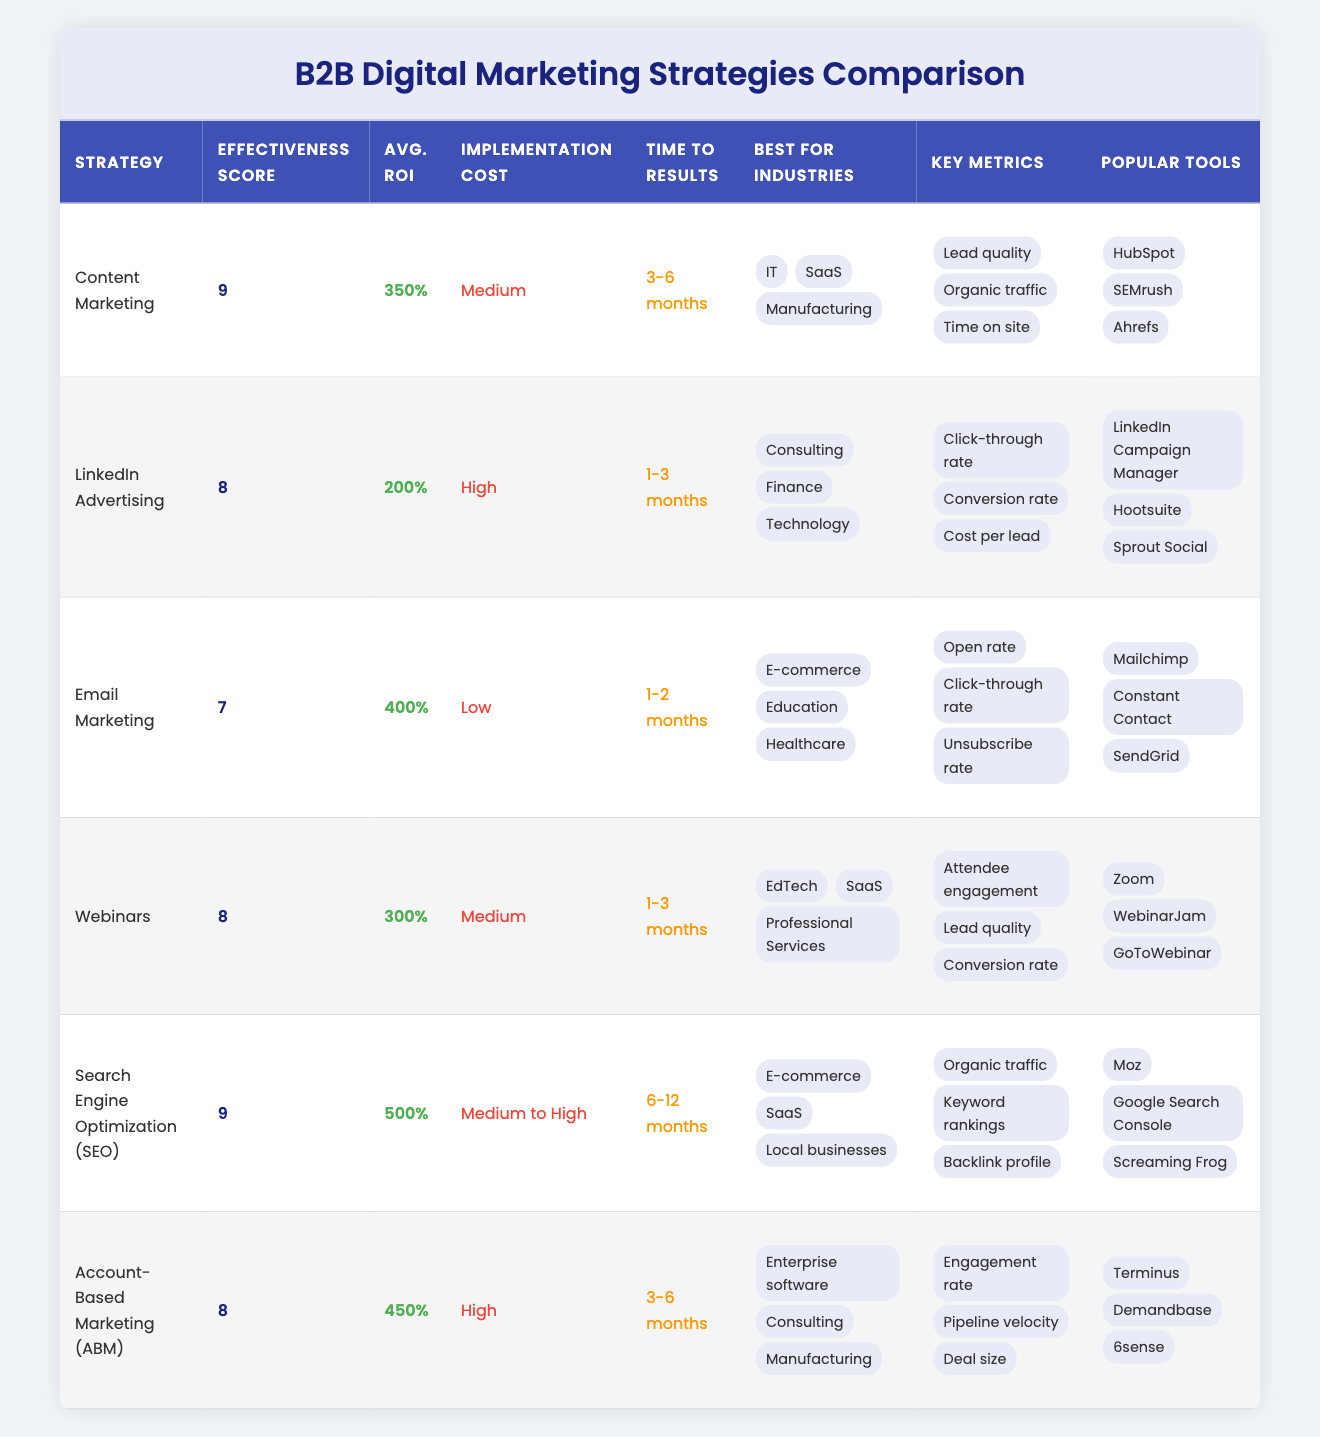What is the effectiveness score of Search Engine Optimization (SEO)? The effectiveness score for Search Engine Optimization (SEO) is listed directly in the table under the effectiveness score column. It shows a score of 9.
Answer: 9 Which digital marketing strategy has the highest average ROI? The average ROI values are provided in the table, and by comparing them, we see that Search Engine Optimization (SEO) has the highest average ROI of 500%.
Answer: 500% Is Email Marketing more effective than LinkedIn Advertising? By comparing the effectiveness scores, Email Marketing has a score of 7 while LinkedIn Advertising has a score of 8. Since 8 is greater than 7, Email Marketing is not more effective than LinkedIn Advertising.
Answer: No What are the time to results for Account-Based Marketing (ABM) and Webinars? The time to results can be found in the table for both strategies. ABM has a time to results of 3-6 months, while Webinars have a time to results of 1-3 months.
Answer: 3-6 months for ABM, 1-3 months for Webinars Which strategy is best for E-commerce? To determine the best strategy for E-commerce, we look at the "Best for Industries" column and find Email Marketing and Search Engine Optimization (SEO) listed under it. This indicates that both strategies are effective for the E-commerce industry.
Answer: Email Marketing and SEO 